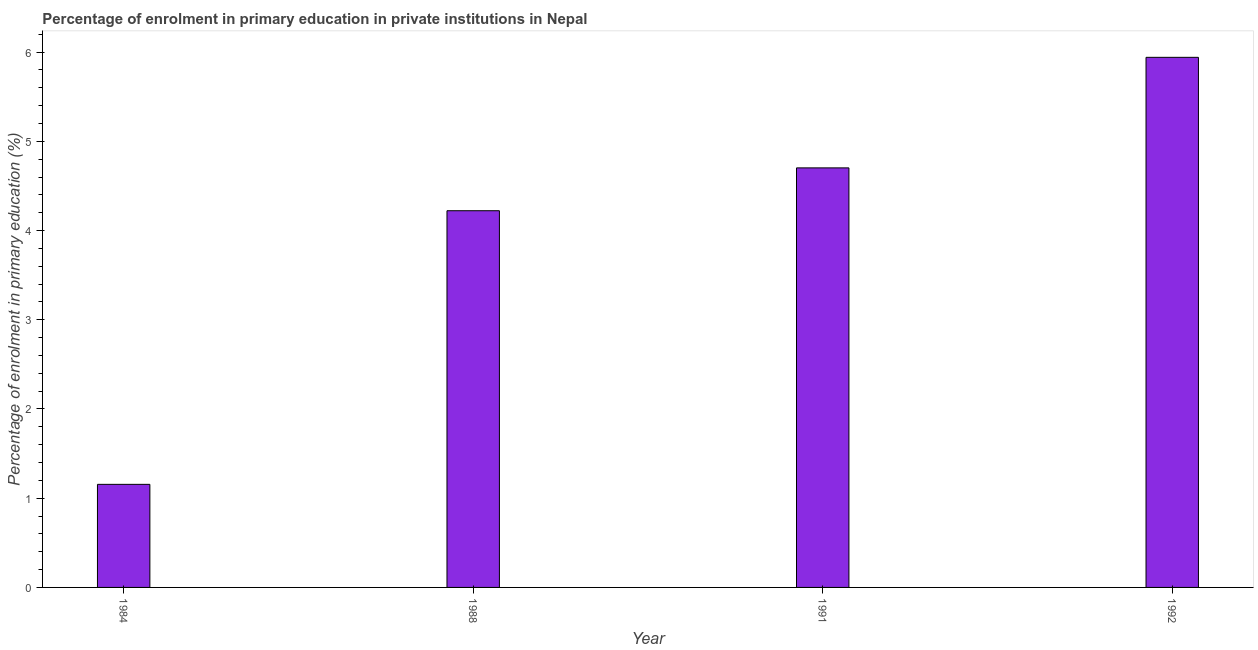Does the graph contain any zero values?
Your answer should be very brief. No. Does the graph contain grids?
Keep it short and to the point. No. What is the title of the graph?
Keep it short and to the point. Percentage of enrolment in primary education in private institutions in Nepal. What is the label or title of the X-axis?
Give a very brief answer. Year. What is the label or title of the Y-axis?
Make the answer very short. Percentage of enrolment in primary education (%). What is the enrolment percentage in primary education in 1988?
Offer a terse response. 4.22. Across all years, what is the maximum enrolment percentage in primary education?
Ensure brevity in your answer.  5.94. Across all years, what is the minimum enrolment percentage in primary education?
Make the answer very short. 1.16. In which year was the enrolment percentage in primary education minimum?
Your response must be concise. 1984. What is the sum of the enrolment percentage in primary education?
Your answer should be compact. 16.02. What is the difference between the enrolment percentage in primary education in 1984 and 1988?
Your answer should be compact. -3.07. What is the average enrolment percentage in primary education per year?
Keep it short and to the point. 4.01. What is the median enrolment percentage in primary education?
Keep it short and to the point. 4.46. In how many years, is the enrolment percentage in primary education greater than 6 %?
Provide a short and direct response. 0. What is the ratio of the enrolment percentage in primary education in 1988 to that in 1992?
Provide a succinct answer. 0.71. What is the difference between the highest and the second highest enrolment percentage in primary education?
Your answer should be compact. 1.24. Is the sum of the enrolment percentage in primary education in 1984 and 1988 greater than the maximum enrolment percentage in primary education across all years?
Offer a terse response. No. What is the difference between the highest and the lowest enrolment percentage in primary education?
Your response must be concise. 4.79. Are all the bars in the graph horizontal?
Provide a short and direct response. No. How many years are there in the graph?
Offer a terse response. 4. What is the difference between two consecutive major ticks on the Y-axis?
Ensure brevity in your answer.  1. Are the values on the major ticks of Y-axis written in scientific E-notation?
Give a very brief answer. No. What is the Percentage of enrolment in primary education (%) of 1984?
Make the answer very short. 1.16. What is the Percentage of enrolment in primary education (%) of 1988?
Make the answer very short. 4.22. What is the Percentage of enrolment in primary education (%) in 1991?
Offer a very short reply. 4.7. What is the Percentage of enrolment in primary education (%) of 1992?
Keep it short and to the point. 5.94. What is the difference between the Percentage of enrolment in primary education (%) in 1984 and 1988?
Your response must be concise. -3.07. What is the difference between the Percentage of enrolment in primary education (%) in 1984 and 1991?
Your answer should be very brief. -3.55. What is the difference between the Percentage of enrolment in primary education (%) in 1984 and 1992?
Make the answer very short. -4.79. What is the difference between the Percentage of enrolment in primary education (%) in 1988 and 1991?
Your answer should be very brief. -0.48. What is the difference between the Percentage of enrolment in primary education (%) in 1988 and 1992?
Provide a short and direct response. -1.72. What is the difference between the Percentage of enrolment in primary education (%) in 1991 and 1992?
Provide a short and direct response. -1.24. What is the ratio of the Percentage of enrolment in primary education (%) in 1984 to that in 1988?
Keep it short and to the point. 0.27. What is the ratio of the Percentage of enrolment in primary education (%) in 1984 to that in 1991?
Provide a succinct answer. 0.25. What is the ratio of the Percentage of enrolment in primary education (%) in 1984 to that in 1992?
Your answer should be compact. 0.19. What is the ratio of the Percentage of enrolment in primary education (%) in 1988 to that in 1991?
Give a very brief answer. 0.9. What is the ratio of the Percentage of enrolment in primary education (%) in 1988 to that in 1992?
Your answer should be compact. 0.71. What is the ratio of the Percentage of enrolment in primary education (%) in 1991 to that in 1992?
Ensure brevity in your answer.  0.79. 